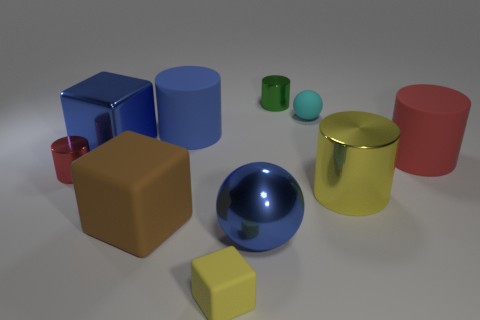Subtract all yellow cylinders. How many cylinders are left? 4 Subtract all big blue cylinders. How many cylinders are left? 4 Subtract all gray cylinders. Subtract all purple blocks. How many cylinders are left? 5 Subtract all blocks. How many objects are left? 7 Subtract all tiny yellow objects. Subtract all big blue cubes. How many objects are left? 8 Add 8 tiny cyan things. How many tiny cyan things are left? 9 Add 2 small cyan spheres. How many small cyan spheres exist? 3 Subtract 0 purple cylinders. How many objects are left? 10 